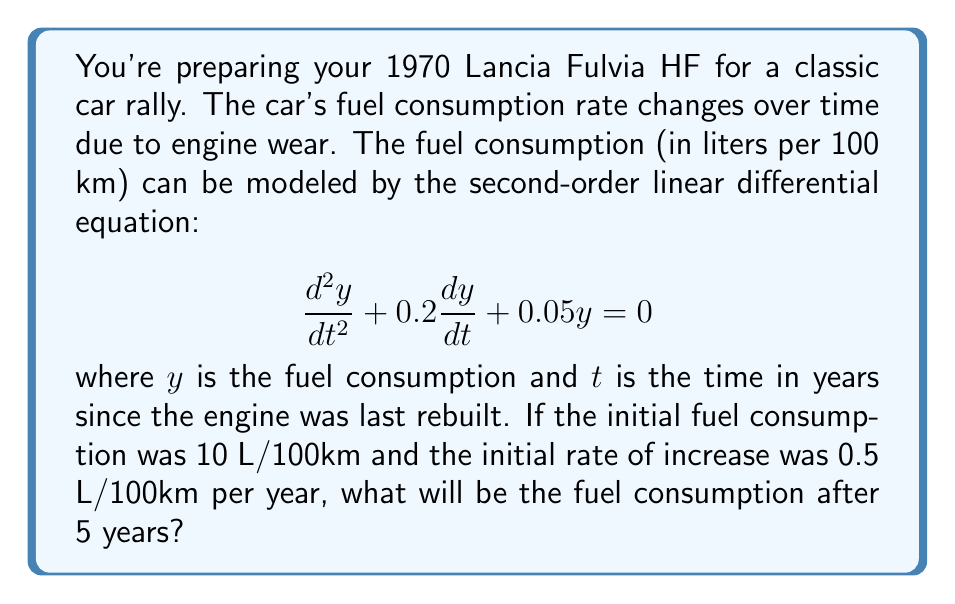Teach me how to tackle this problem. To solve this problem, we need to follow these steps:

1) The general solution for this second-order linear differential equation is:

   $$y = C_1e^{r_1t} + C_2e^{r_2t}$$

   where $r_1$ and $r_2$ are the roots of the characteristic equation:

   $$r^2 + 0.2r + 0.05 = 0$$

2) Solving the characteristic equation:
   
   $$r = \frac{-0.2 \pm \sqrt{0.2^2 - 4(0.05)}}{2} = \frac{-0.2 \pm \sqrt{0.04 - 0.2}}{2} = \frac{-0.2 \pm \sqrt{-0.16}}{2}$$

   $$r = -0.1 \pm 0.2i$$

3) Therefore, the general solution is:

   $$y = e^{-0.1t}(C_1\cos(0.2t) + C_2\sin(0.2t))$$

4) We have two initial conditions:
   
   At $t=0$, $y(0) = 10$ and $y'(0) = 0.5$

5) Using the first condition:

   $$10 = C_1$$

6) For the second condition, we need to differentiate $y$:

   $$y' = -0.1e^{-0.1t}(C_1\cos(0.2t) + C_2\sin(0.2t)) + e^{-0.1t}(-0.2C_1\sin(0.2t) + 0.2C_2\cos(0.2t))$$

   At $t=0$:

   $$0.5 = -0.1C_1 + 0.2C_2$$

7) Substituting $C_1 = 10$:

   $$0.5 = -1 + 0.2C_2$$
   $$C_2 = 7.5$$

8) Therefore, the particular solution is:

   $$y = e^{-0.1t}(10\cos(0.2t) + 7.5\sin(0.2t))$$

9) To find the fuel consumption after 5 years, we substitute $t=5$:

   $$y(5) = e^{-0.5}(10\cos(1) + 7.5\sin(1))$$

10) Calculating this:

    $$y(5) \approx 0.6065 * (10 * 0.5403 + 7.5 * 0.8415) \approx 7.1843$$
Answer: The fuel consumption after 5 years will be approximately 7.18 L/100km. 